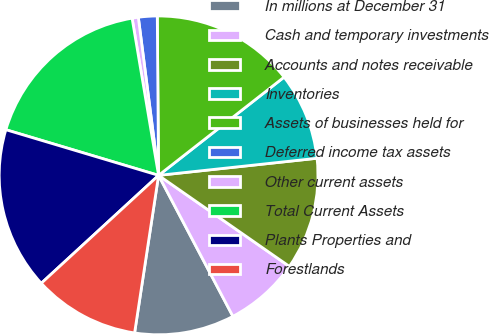Convert chart. <chart><loc_0><loc_0><loc_500><loc_500><pie_chart><fcel>In millions at December 31<fcel>Cash and temporary investments<fcel>Accounts and notes receivable<fcel>Inventories<fcel>Assets of businesses held for<fcel>Deferred income tax assets<fcel>Other current assets<fcel>Total Current Assets<fcel>Plants Properties and<fcel>Forestlands<nl><fcel>10.13%<fcel>7.6%<fcel>11.39%<fcel>8.86%<fcel>14.56%<fcel>1.9%<fcel>0.63%<fcel>17.72%<fcel>16.46%<fcel>10.76%<nl></chart> 